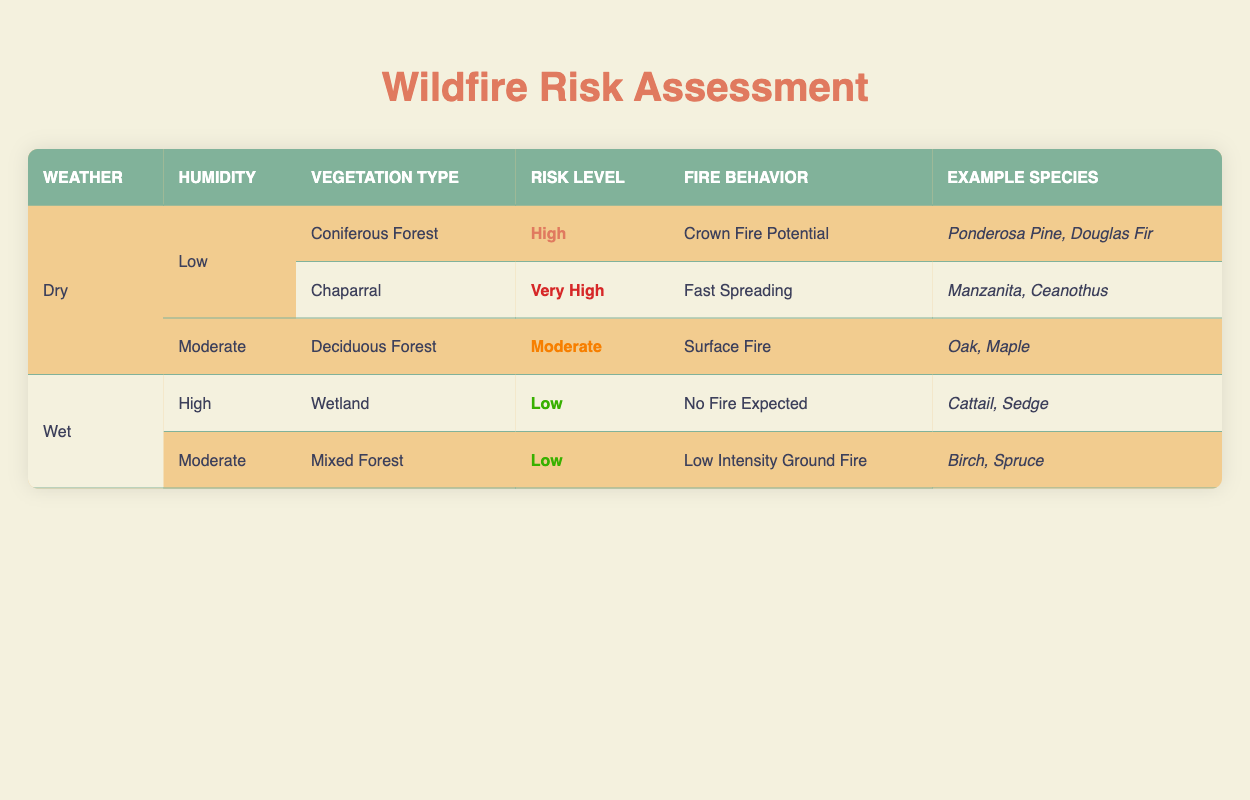What is the risk level for Coniferous Forest in Dry and Low humidity conditions? The table lists the vegetation types under specific weather and humidity conditions. For the "Dry" weather and "Low" humidity, the "Coniferous Forest" has a risk level categorized as "High."
Answer: High Which Vegetation Type has the highest fire risk in Dry and Low humidity? From the table, under "Dry" weather and "Low" humidity, the "Chaparral" vegetation type has a risk level of "Very High," which is higher than the "Coniferous Forest."
Answer: Chaparral Is there any type of vegetation that has a low risk level in Wet conditions? According to the table, both "Wetland" and "Mixed Forest" have "Low" risk levels under "Wet" conditions, confirming there are vegetation types with low risk.
Answer: Yes What behavior is expected for the Deciduous Forest in Dry and Moderate humidity? For "Dry" weather and "Moderate" humidity, the "Deciduous Forest" is categorized as having a "Moderate" risk level with "Surface Fire" behavior expected, as directly listed in the table.
Answer: Surface Fire Which example species are associated with the Wetland vegetation type? The table specifies that the "Wetland" vegetation type corresponds to the example species "Cattail" and "Sedge."
Answer: Cattail, Sedge If I consider all vegetation types in Wet conditions, what is the total number of example species listed? Under "Wet" conditions, the "Wetland" lists 2 species (Cattail, Sedge) and the "Mixed Forest" also lists 2 species (Birch, Spruce). Therefore, the total is 2 + 2 = 4 species.
Answer: 4 What is the fire behavior for Chaparral in Dry and Low humidity? Referring to the "Chaparral" under "Dry" and "Low" humidity conditions, the table lists the fire behavior as "Fast Spreading."
Answer: Fast Spreading In what condition does a Low risk level occur for the Mixed Forest? The "Mixed Forest" under "Wet" conditions shows a "Moderate" humidity level with a risk classification of "Low," as indicated in the table.
Answer: Moderate humidity in Wet conditions Is there any vegetation type listed that does not have a risk level of High or Very High in Dry conditions? Yes, in the Dry conditions under Moderate humidity, the "Deciduous Forest" has a "Moderate" risk level, which is neither High nor Very High.
Answer: Yes 